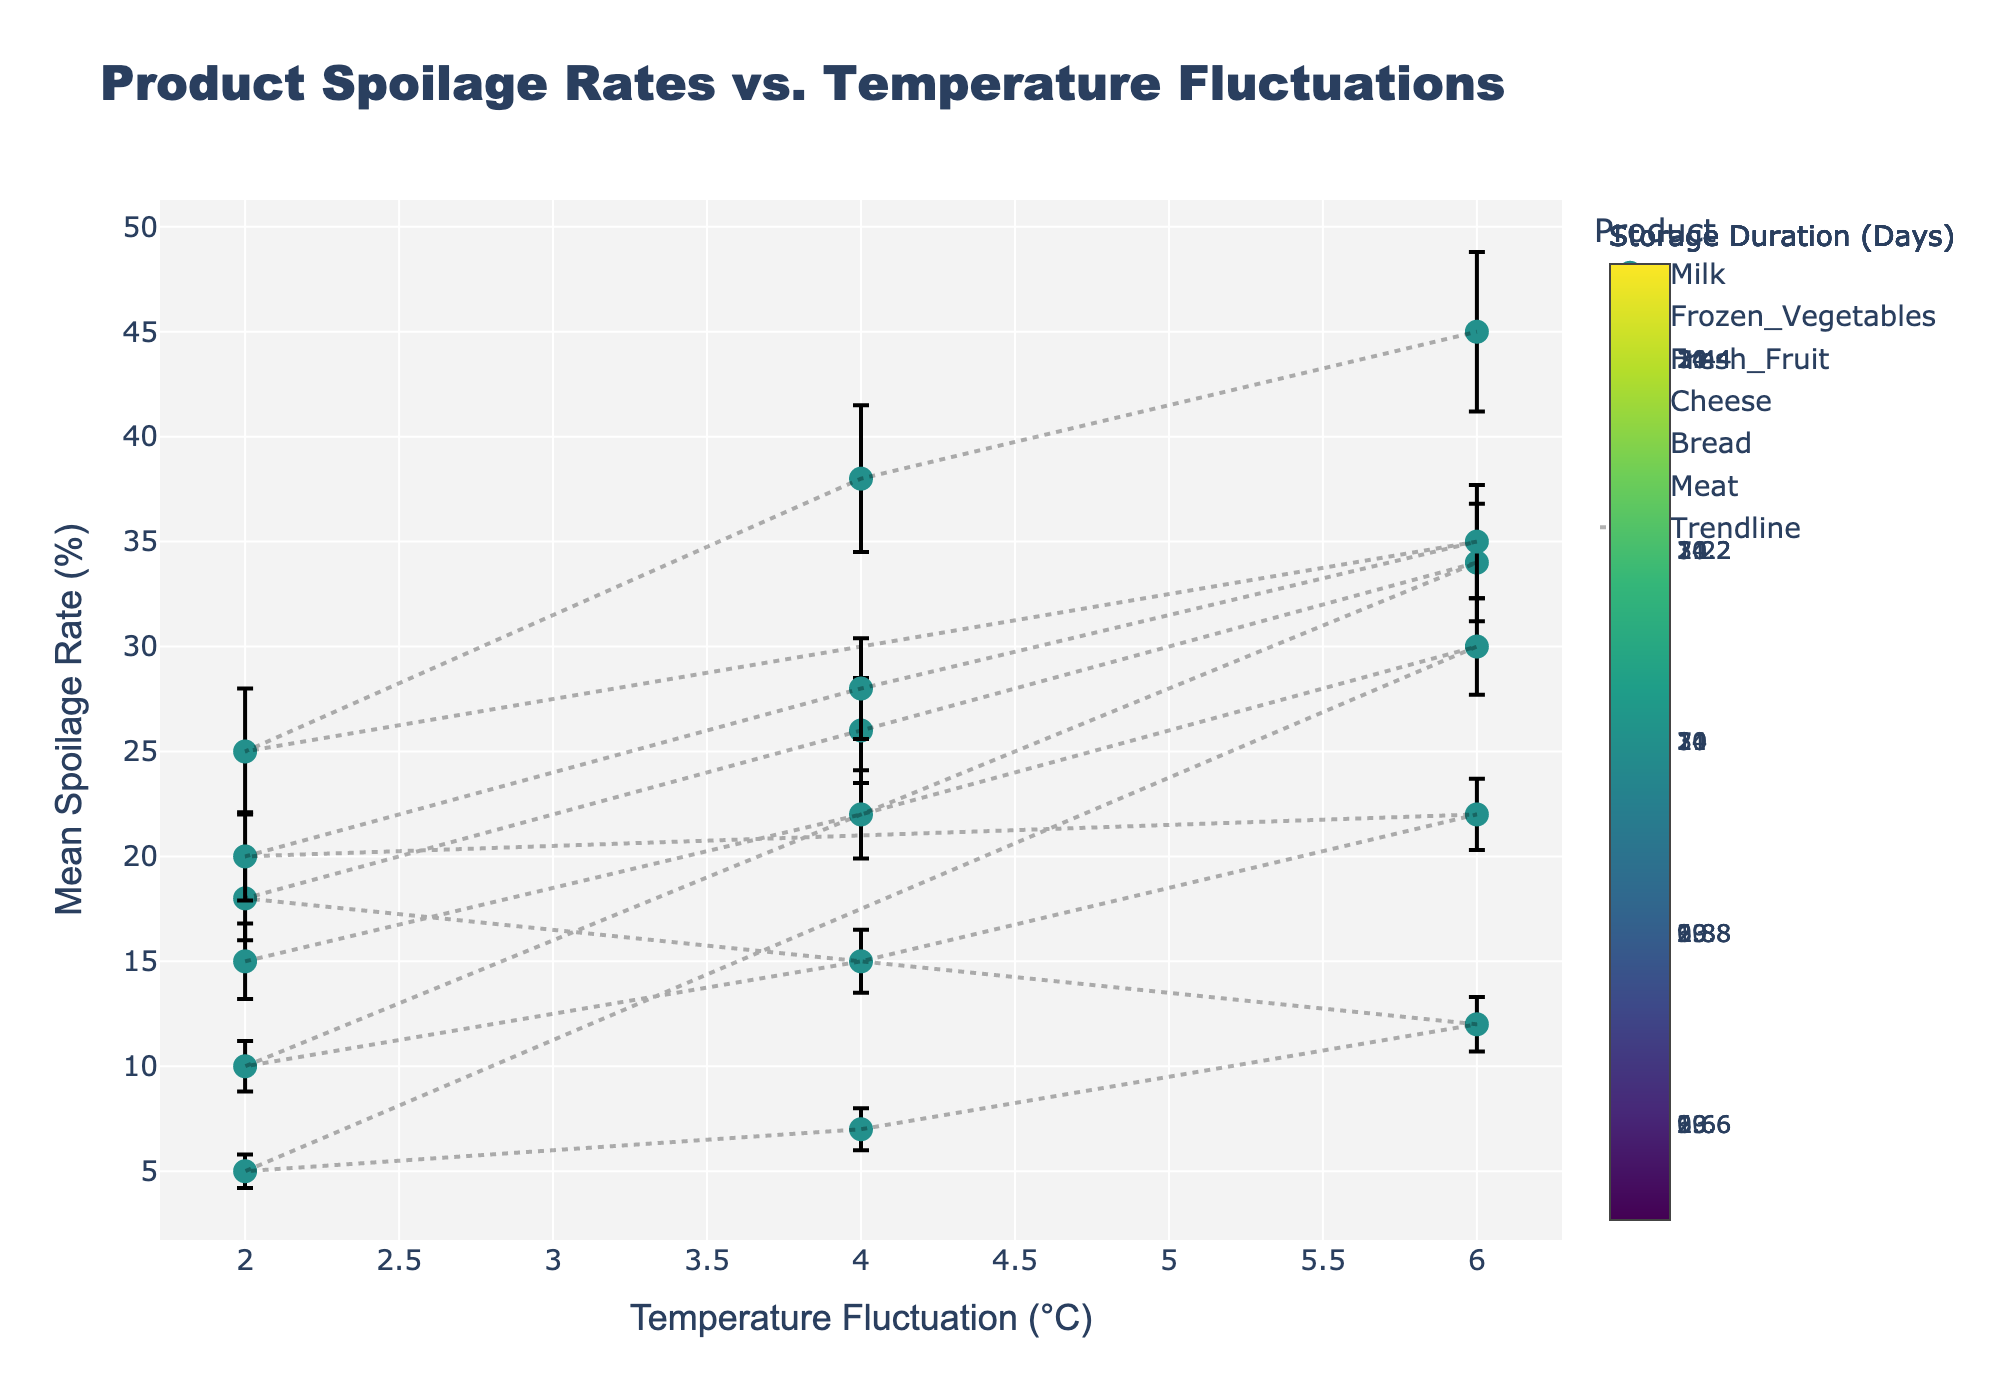What's the general trend in spoilage rates as temperature fluctuations increase for most products? The mean spoilage rate tends to increase as temperature fluctuations rise from 2°C to 6°C for most products, indicating that higher temperature variability generally leads to higher spoilage rates.
Answer: Increase What is the highest mean spoilage rate observed, and for which product and temperature fluctuation is it recorded? The highest mean spoilage rate is 45%, observed for Meat at 6°C temperature fluctuation.
Answer: 45%, Meat, 6°C Which product has the lowest mean spoilage rate at 2°C temperature fluctuation, and what is the value? Frozen Vegetables have the lowest mean spoilage rate at 2°C temperature fluctuation, with a value of 5%.
Answer: Frozen Vegetables, 5% Comparing milk and bread, which product shows a higher mean spoilage rate at 4°C temperature fluctuation, and what are the respective rates? At a 4°C temperature fluctuation, Bread has a mean spoilage rate of 28%, whereas Milk has a rate of 22%. Bread shows a higher spoilage rate at this temperature fluctuation.
Answer: Bread, 28% How does the error margin (variability) for spoilage rates compare between Fresh Fruit and Cheese at 6°C temperature fluctuation? At a 6°C temperature fluctuation, Fresh Fruit has a spoilage rate error of 2.8%, while Cheese has an error of 1.7%. Fresh Fruit has a larger error margin compared to Cheese.
Answer: Fresh Fruit, 2.8%; Cheese, 1.7% What is the difference in mean spoilage rates between Fresh Fruit and Meat at a 2°C temperature fluctuation? Fresh Fruit has a mean spoilage rate of 18% at a 2°C temperature fluctuation, whereas Meat has a mean spoilage rate of 25% at the same temperature fluctuation. The difference is 25% - 18% = 7%.
Answer: 7% Which product shows the least increase in mean spoilage rate when the temperature fluctuation increases from 2°C to 4°C, and what is the rate of increase? Frozen Vegetables show the least increase in mean spoilage rate when the temperature fluctuation increases from 2°C to 4°C, with an increase of 7% - 5% = 2%.
Answer: Frozen Vegetables, 2% If the error bars for spoilage rates overlap significantly, what does this imply about the reliability of the mean spoilage rates for those conditions? Significant overlap in error bars suggests that there is considerable variability in the spoilage rates, which implies that the mean rates may not be significantly different from each other, reducing the reliability of any conclusions drawn about differences.
Answer: Reduced reliability 